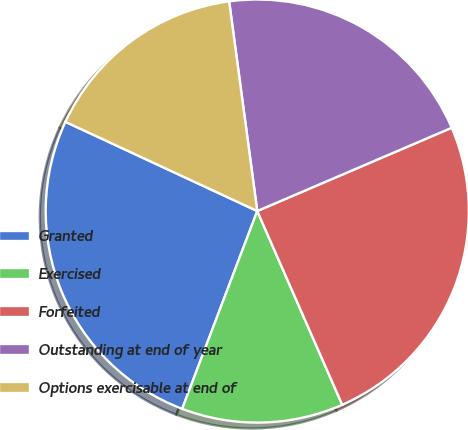Convert chart to OTSL. <chart><loc_0><loc_0><loc_500><loc_500><pie_chart><fcel>Granted<fcel>Exercised<fcel>Forfeited<fcel>Outstanding at end of year<fcel>Options exercisable at end of<nl><fcel>26.15%<fcel>12.35%<fcel>24.86%<fcel>20.68%<fcel>15.95%<nl></chart> 